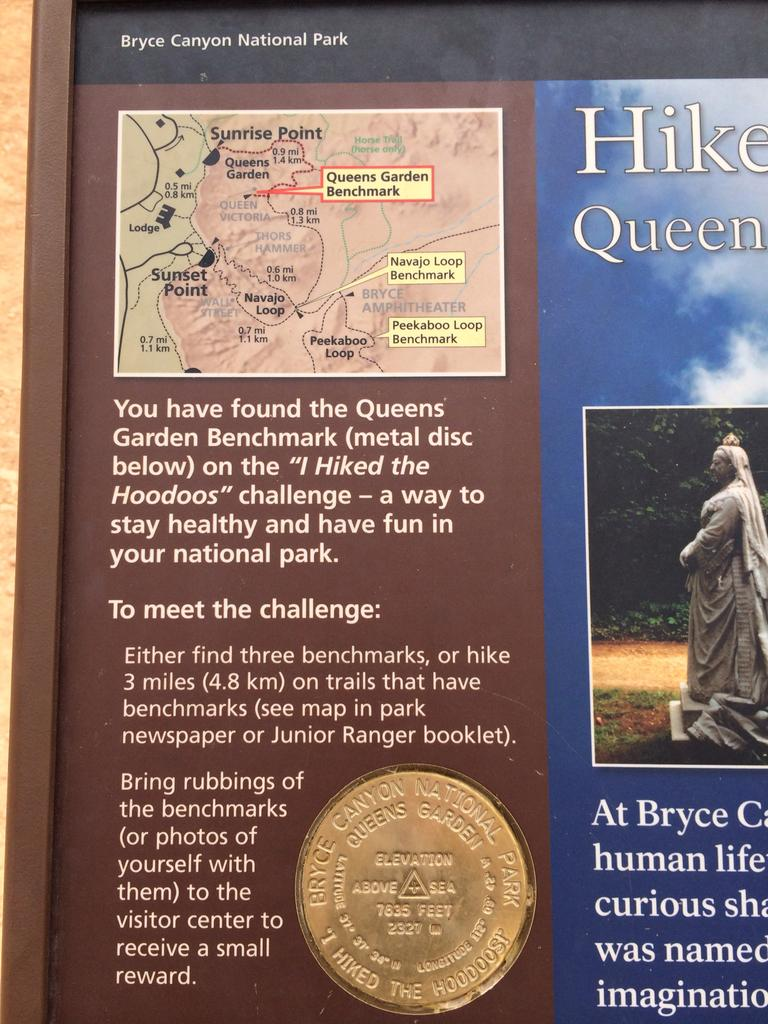<image>
Provide a brief description of the given image. A Bryce Canyon Notional Park sign gives information about the Queens Garden Benchmark. 